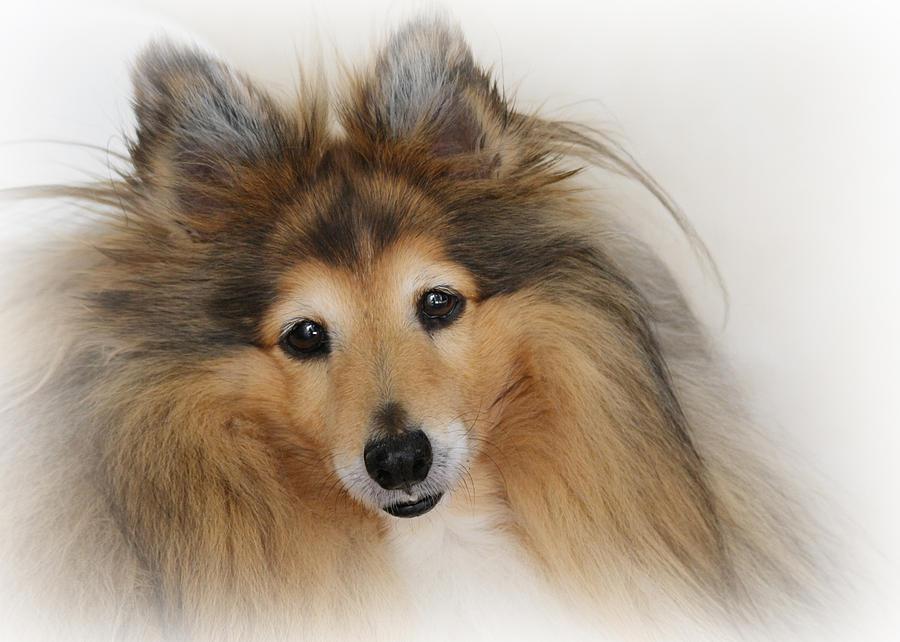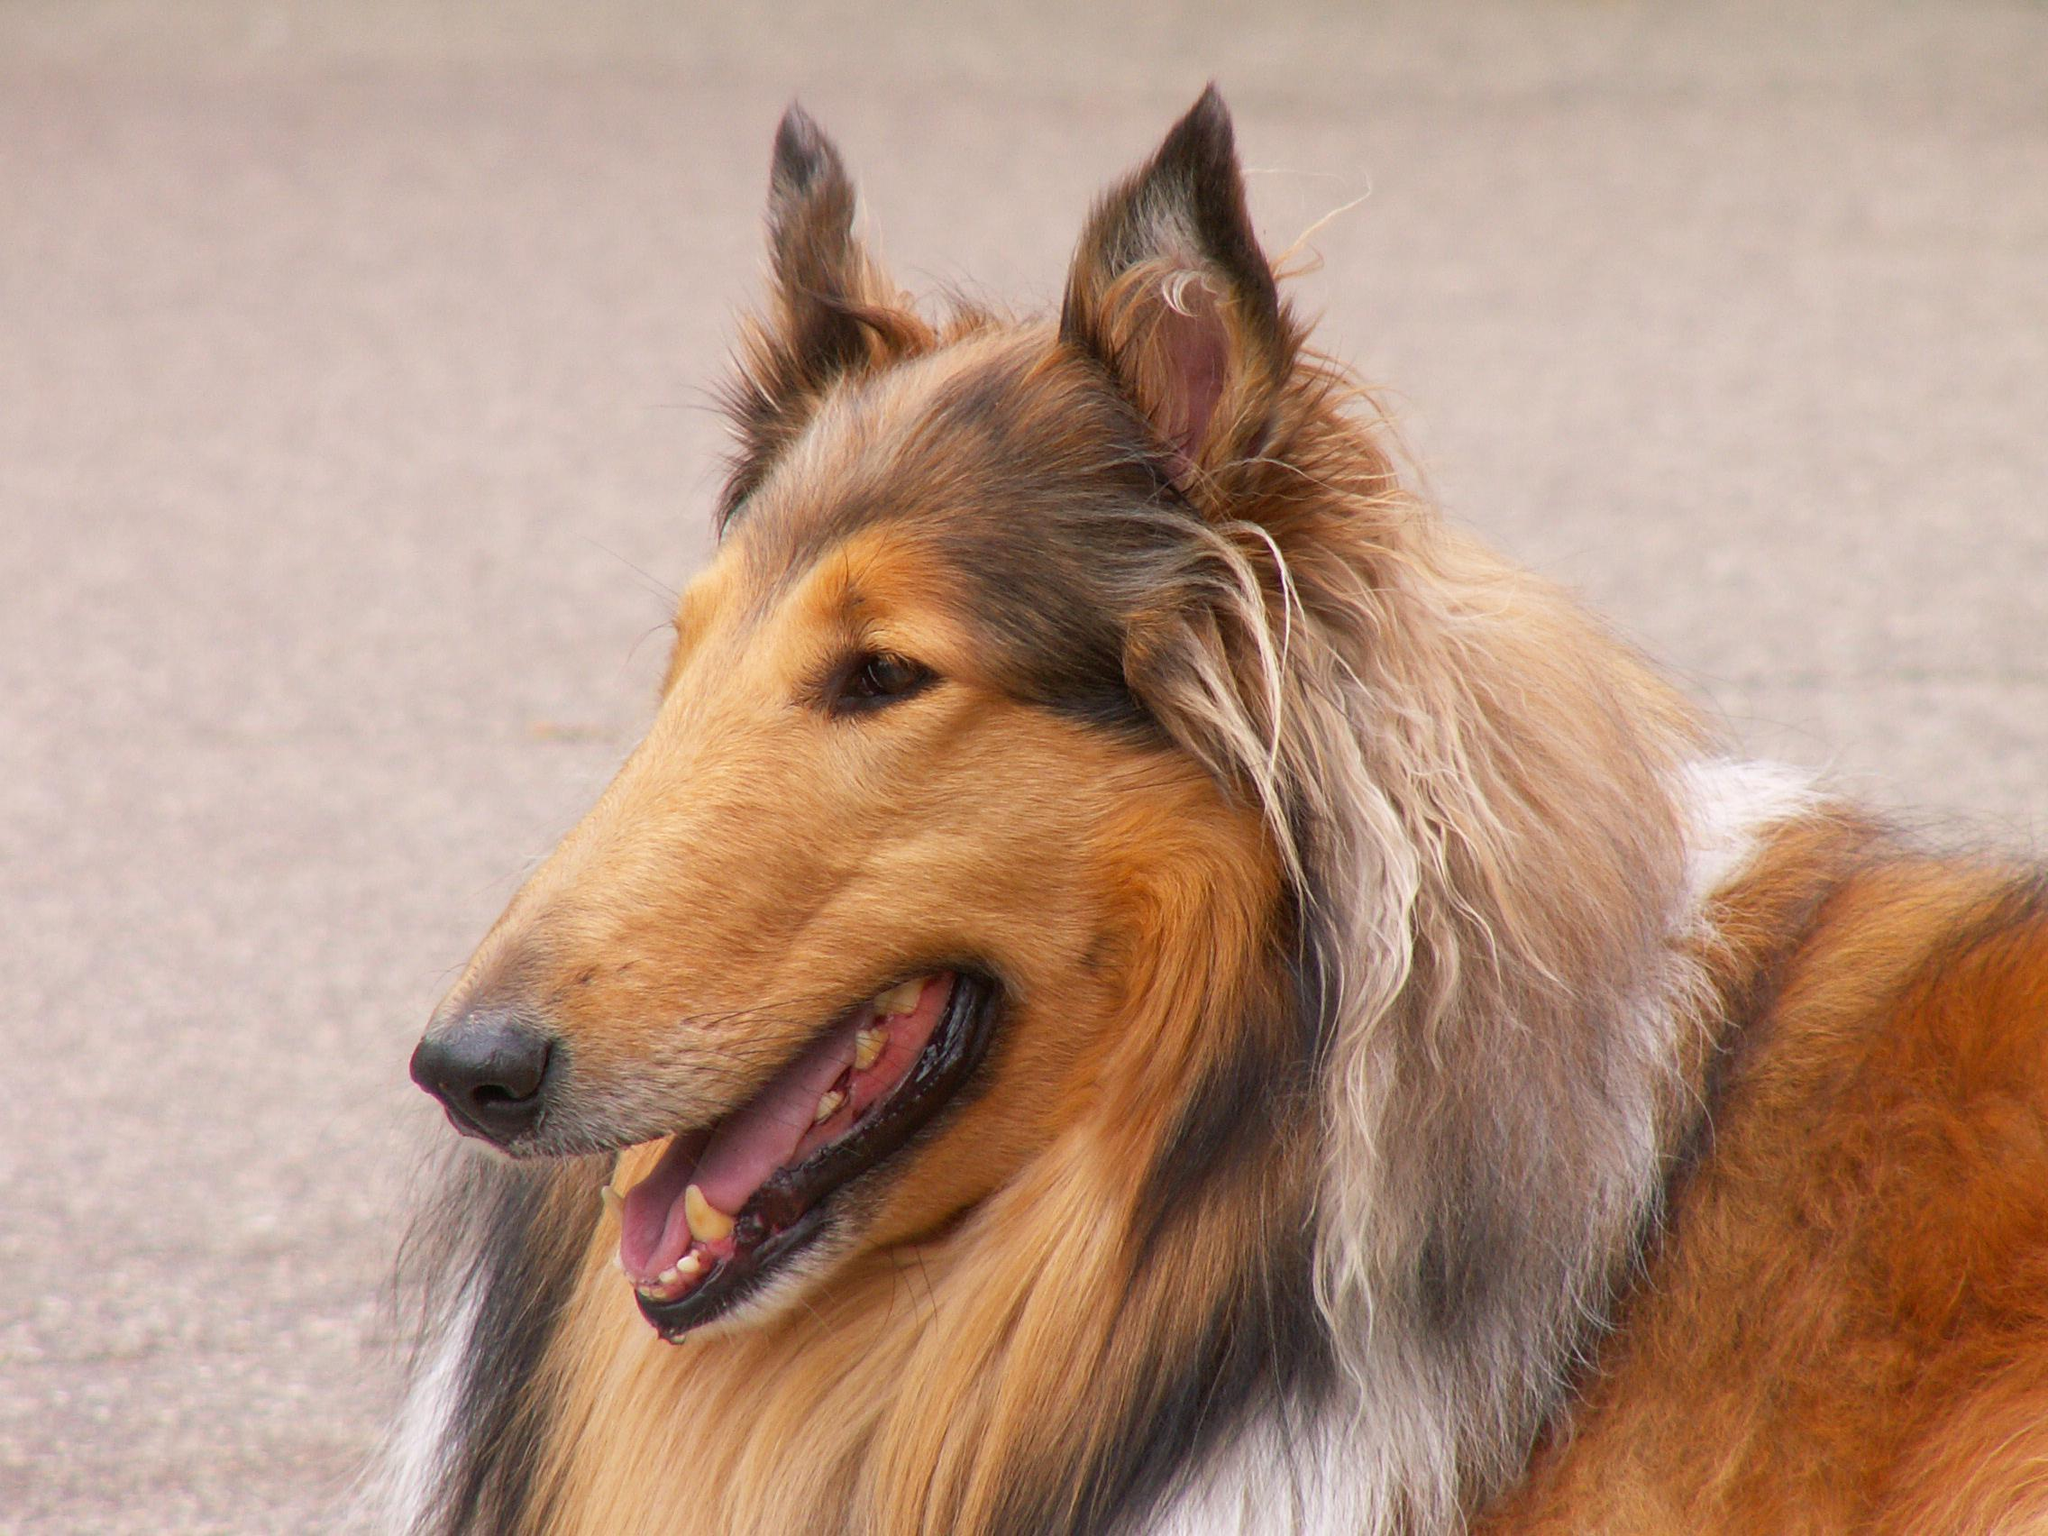The first image is the image on the left, the second image is the image on the right. Analyze the images presented: Is the assertion "The left image features a collie on a mottled, non-white portrait background." valid? Answer yes or no. No. 